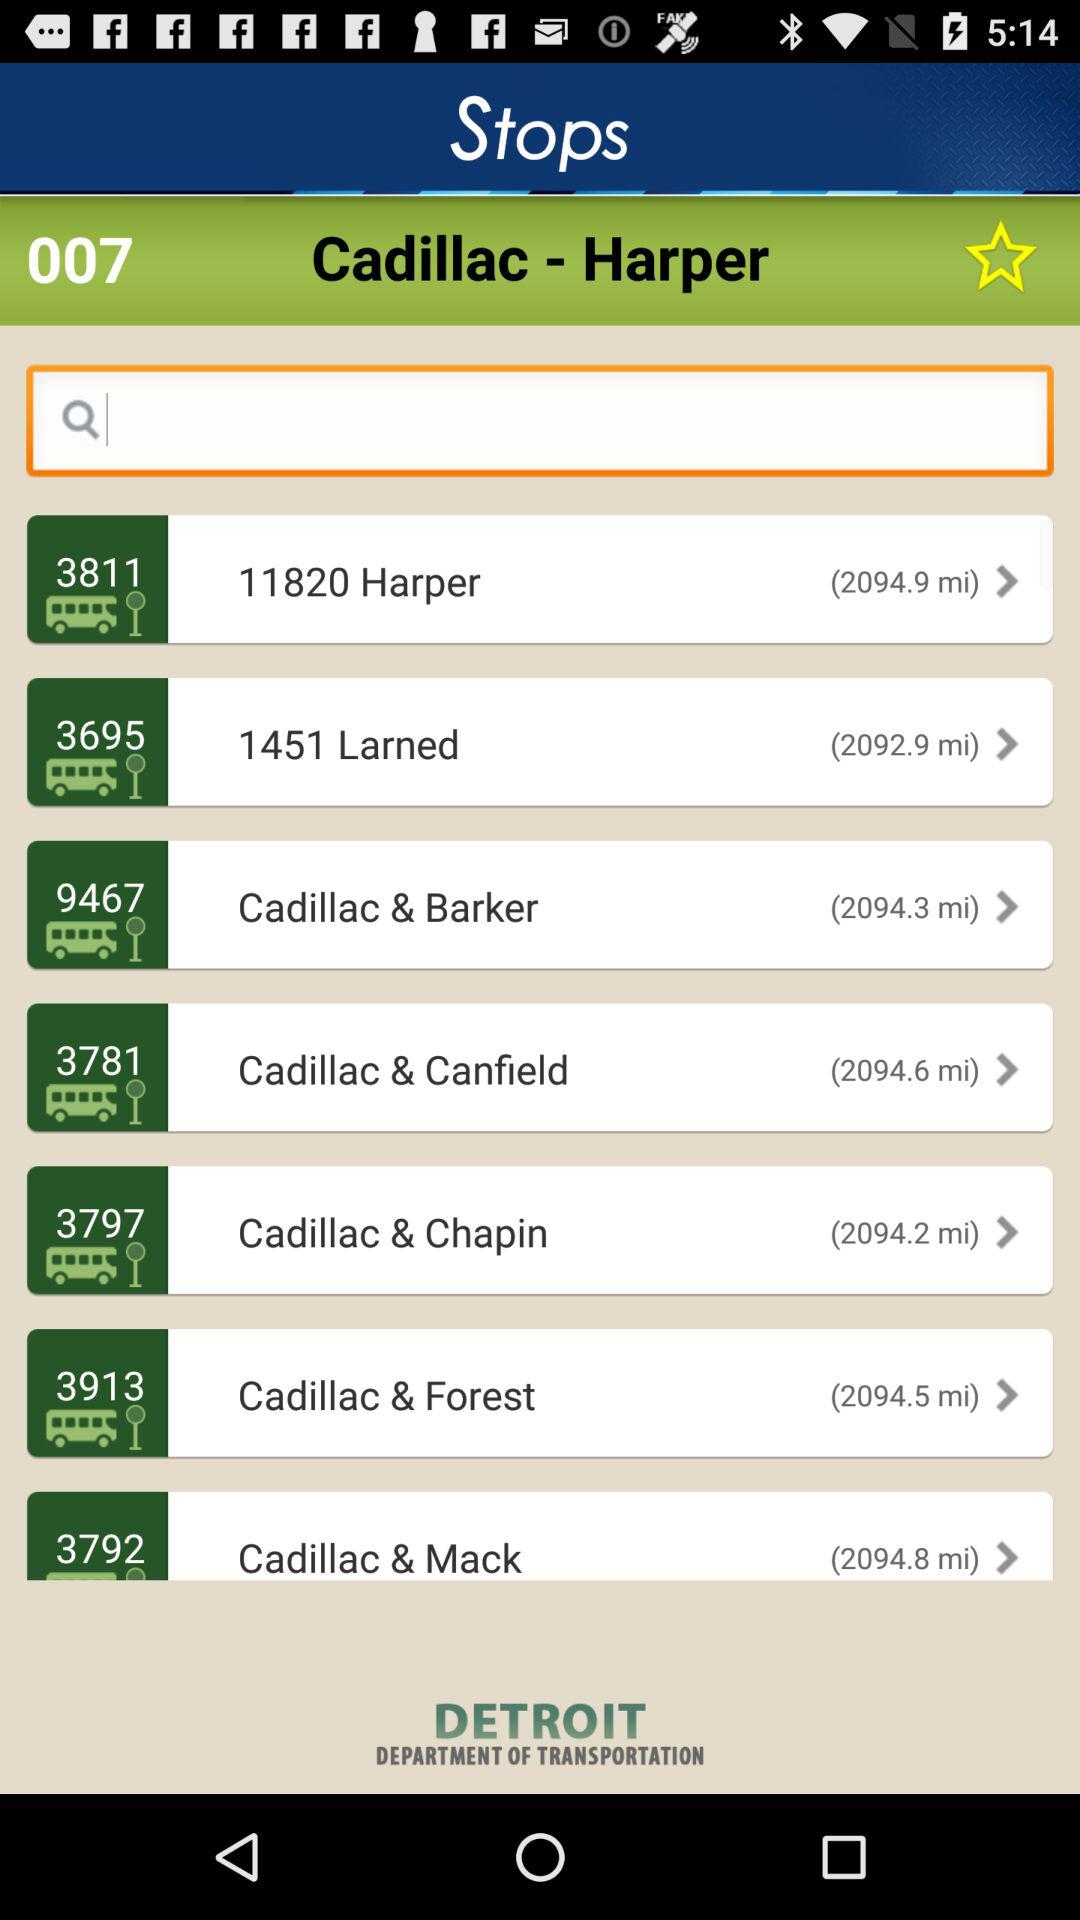What is the stated distance between Cadillac and Chapin? The stated distance between Cadillac and Chapin is 2094.2 miles. 